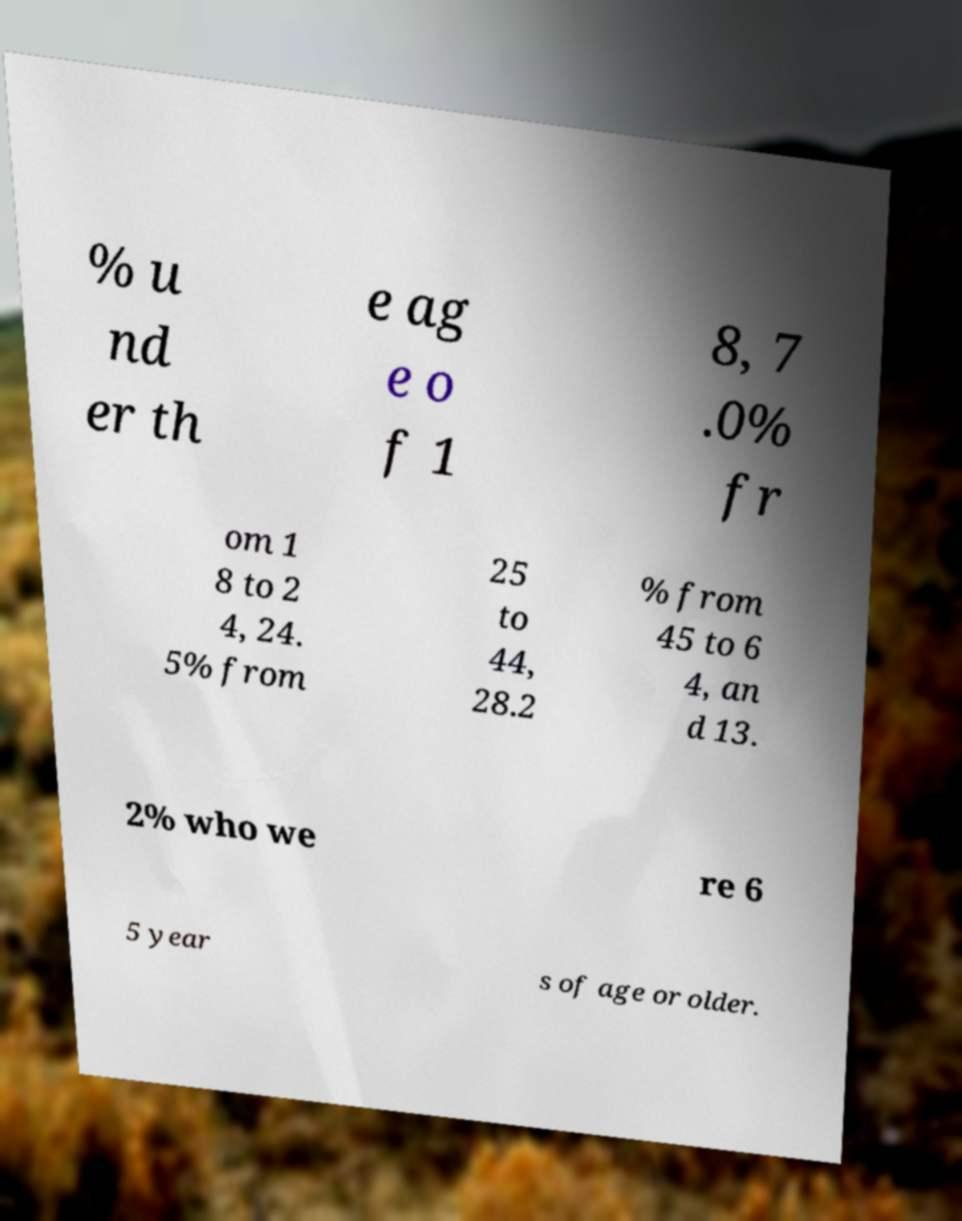For documentation purposes, I need the text within this image transcribed. Could you provide that? % u nd er th e ag e o f 1 8, 7 .0% fr om 1 8 to 2 4, 24. 5% from 25 to 44, 28.2 % from 45 to 6 4, an d 13. 2% who we re 6 5 year s of age or older. 